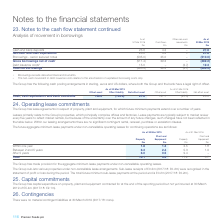According to Premier Foods Plc's financial document, What was the property payment within between 2 and 5 years in 2019? According to the financial document, 6.3 (in millions). The relevant text states: "in one year 1.8 1.3 2.5 1.8 Between 2 and 5 years 6.3 2.4 5.3 1.9 After 5 years 6.0 0.5 9.4 –..." Also, What was the total property payment in 2019? According to the financial document, 14.1 (in millions). The relevant text states: "Total 14.1 4.2 17.2 3.7..." Also, What was the property payment within one year in 2019? According to the financial document, 1.8 (in millions). The relevant text states: "Plant and Equipment £m Within one year 1.8 1.3 2.5 1.8 Between 2 and 5 years 6.3 2.4 5.3 1.9 After 5 years 6.0 0.5 9.4 –..." Also, can you calculate: What was the change in the property payment within one year from 2018 to 2019? Based on the calculation: 1.8 - 2.5, the result is -0.7 (in millions). This is based on the information: "Plant and Equipment £m Within one year 1.8 1.3 2.5 1.8 Between 2 and 5 years 6.3 2.4 5.3 1.9 After 5 years 6.0 0.5 9.4 – Plant and Equipment £m Within one year 1.8 1.3 2.5 1.8 Between 2 and 5 years 6...." The key data points involved are: 1.8, 2.5. Also, can you calculate: What is the average plant and equipment payment due between 2 and 5 years in 2018 and 2019? To answer this question, I need to perform calculations using the financial data. The calculation is: (2.4 + 1.9) / 2, which equals 2.15 (in millions). This is based on the information: "ne year 1.8 1.3 2.5 1.8 Between 2 and 5 years 6.3 2.4 5.3 1.9 After 5 years 6.0 0.5 9.4 – 1.8 1.3 2.5 1.8 Between 2 and 5 years 6.3 2.4 5.3 1.9 After 5 years 6.0 0.5 9.4 –..." The key data points involved are: 1.9, 2.4. Also, can you calculate: What is the change in the total property payment due from 2018 to 2019? Based on the calculation: 14.1 - 17.2, the result is -3.1 (in millions). This is based on the information: "Total 14.1 4.2 17.2 3.7 Total 14.1 4.2 17.2 3.7..." The key data points involved are: 14.1, 17.2. 